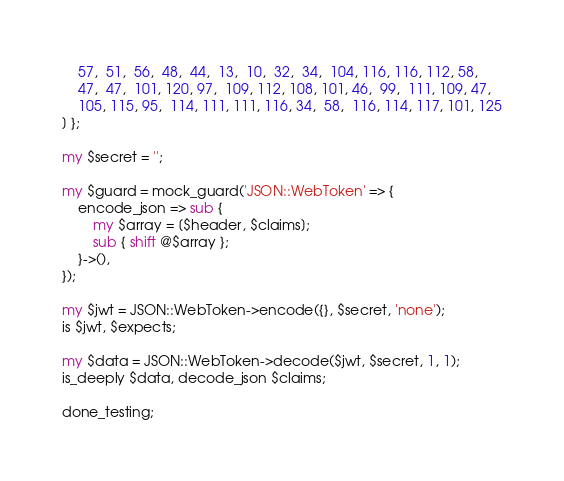<code> <loc_0><loc_0><loc_500><loc_500><_Perl_>    57,  51,  56,  48,  44,  13,  10,  32,  34,  104, 116, 116, 112, 58,
    47,  47,  101, 120, 97,  109, 112, 108, 101, 46,  99,  111, 109, 47,
    105, 115, 95,  114, 111, 111, 116, 34,  58,  116, 114, 117, 101, 125
] };

my $secret = '';

my $guard = mock_guard('JSON::WebToken' => {
    encode_json => sub {
        my $array = [$header, $claims];
        sub { shift @$array };
    }->(),
});

my $jwt = JSON::WebToken->encode({}, $secret, 'none');
is $jwt, $expects;

my $data = JSON::WebToken->decode($jwt, $secret, 1, 1);
is_deeply $data, decode_json $claims;

done_testing;
</code> 